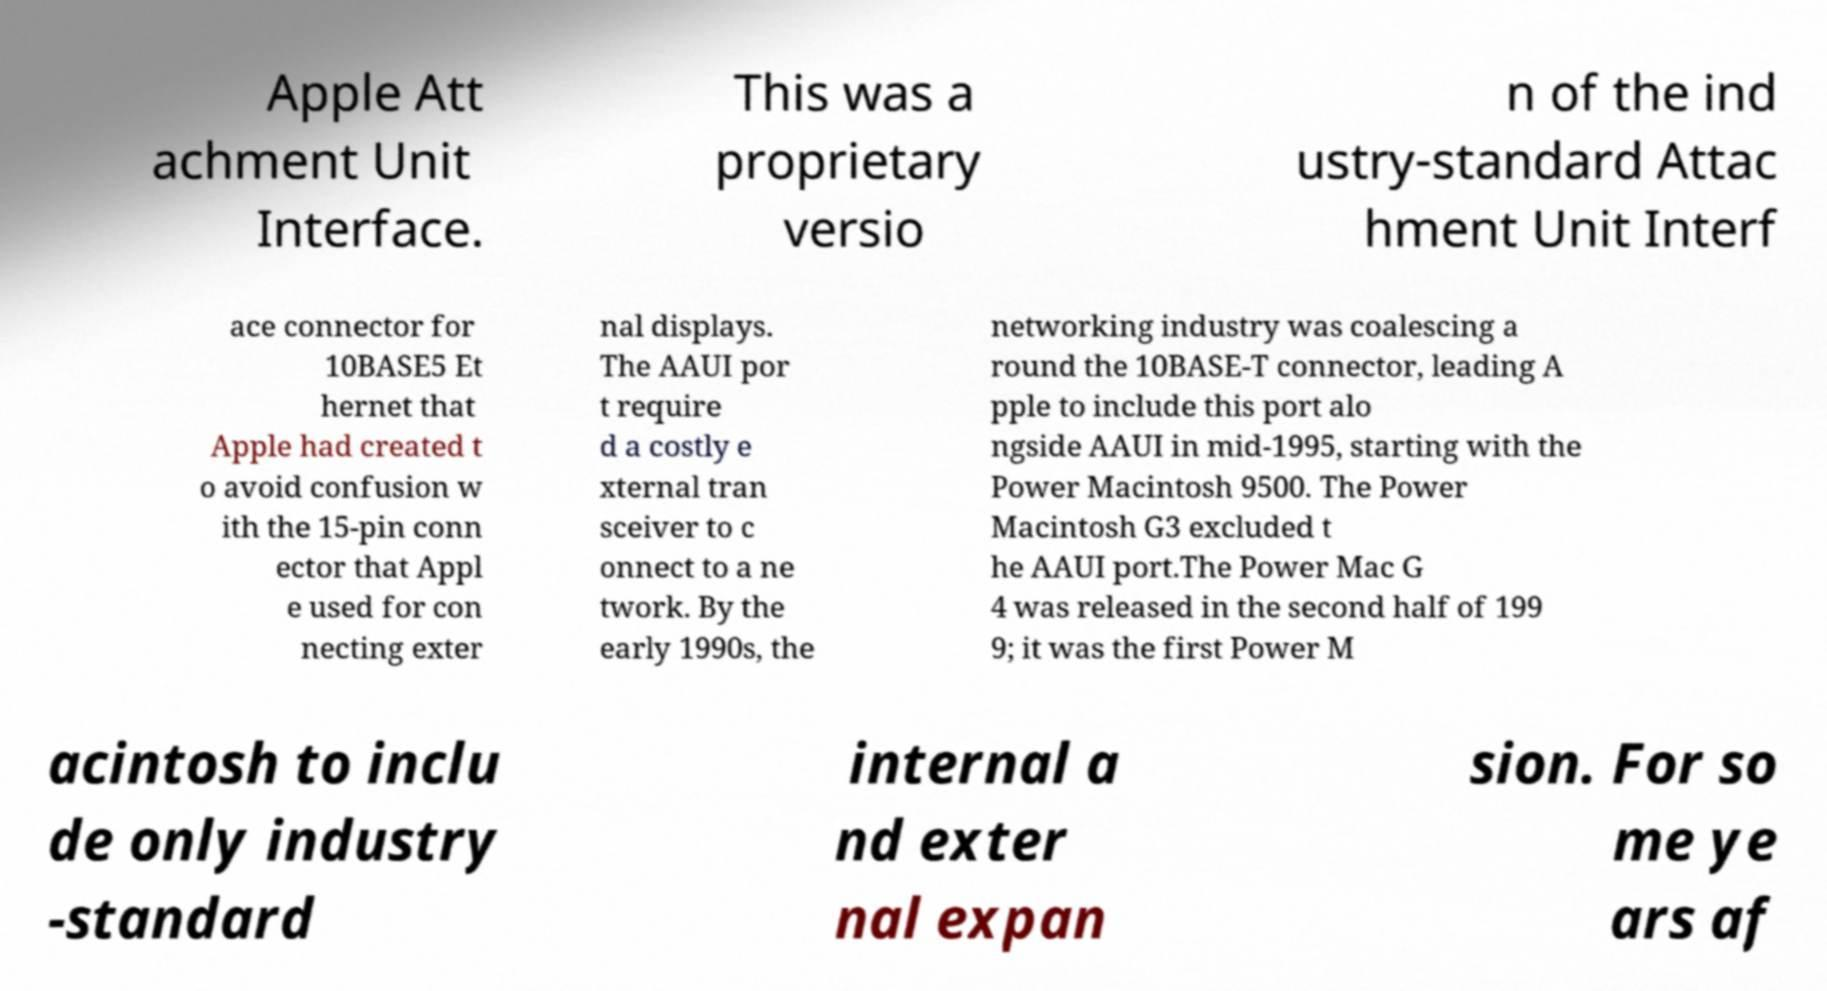Could you assist in decoding the text presented in this image and type it out clearly? Apple Att achment Unit Interface. This was a proprietary versio n of the ind ustry-standard Attac hment Unit Interf ace connector for 10BASE5 Et hernet that Apple had created t o avoid confusion w ith the 15-pin conn ector that Appl e used for con necting exter nal displays. The AAUI por t require d a costly e xternal tran sceiver to c onnect to a ne twork. By the early 1990s, the networking industry was coalescing a round the 10BASE-T connector, leading A pple to include this port alo ngside AAUI in mid-1995, starting with the Power Macintosh 9500. The Power Macintosh G3 excluded t he AAUI port.The Power Mac G 4 was released in the second half of 199 9; it was the first Power M acintosh to inclu de only industry -standard internal a nd exter nal expan sion. For so me ye ars af 